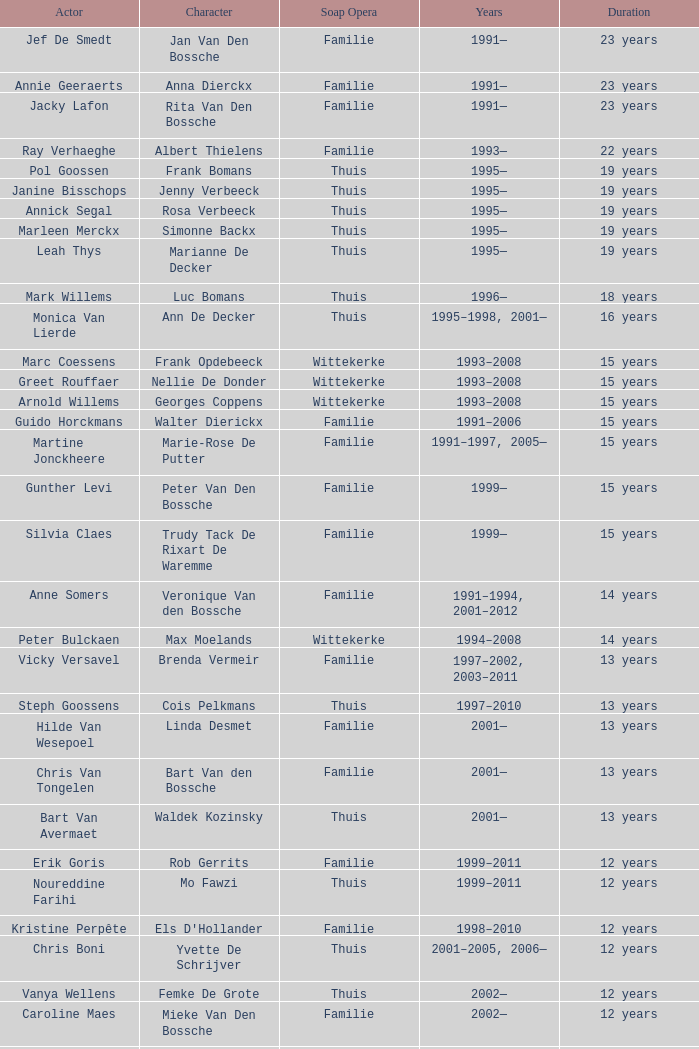What thespian represents marie-rose de putter? Martine Jonckheere. 